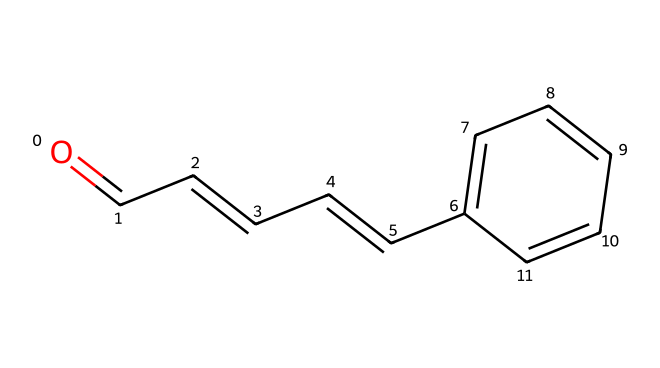what is the name of this chemical? The SMILES representation given is characteristic of cinnamaldehyde, which is known for its cinnamon scent.
Answer: cinnamaldehyde how many carbon atoms are in cinnamaldehyde? By analyzing the SMILES representation, you can count a total of 9 carbon atoms in the structure, including those in the benzene ring and the aldehyde group.
Answer: 9 what functional group is present in cinnamaldehyde? The structure shows a terminal carbonyl group (C=O), typical of aldehydes, indicating the presence of the aldehyde functional group.
Answer: aldehyde how many hydrogen atoms are bonded to carbon in the structure? From the SMILES representation, there are 8 hydrogen atoms connected to carbon (including those attached to the benzene ring and the chain), ensuring each carbon follows the tetravalency rule.
Answer: 8 what type of molecular bonding is exhibited by the C=O functional group? The carbonyl group (C=O) indicates a double bond between carbon and oxygen, which is characteristic of the bonding found in aldehydes.
Answer: double bond how does the presence of the benzene ring influence the properties of cinnamaldehyde? The benzene ring introduces aromatic stability and contributes to the compound's distinct aroma. The interactions of the ring with the functional group affect reactivity and fragrance.
Answer: aromatic stability 